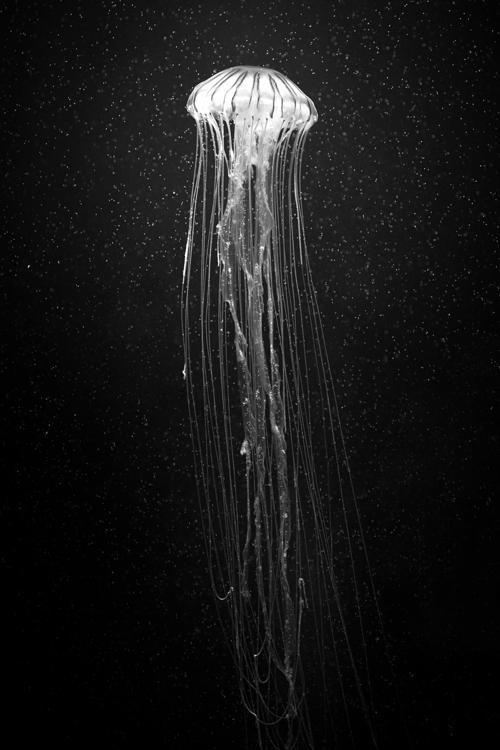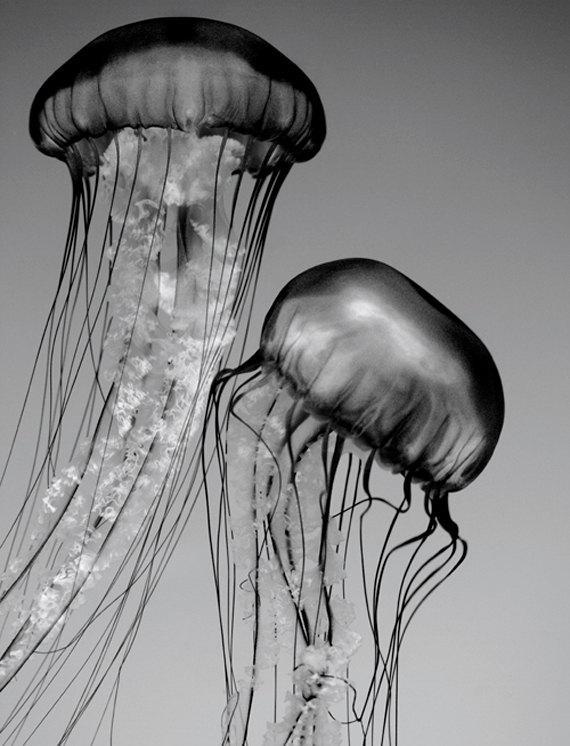The first image is the image on the left, the second image is the image on the right. Analyze the images presented: Is the assertion "The image on the right shows only a single jellyfish swimming to the right." valid? Answer yes or no. No. The first image is the image on the left, the second image is the image on the right. Evaluate the accuracy of this statement regarding the images: "The combined images total no more than three jellyfish, the left shown on black and the right - shown on a lighter background - featuring a dome-topped jellyfish.". Is it true? Answer yes or no. Yes. 